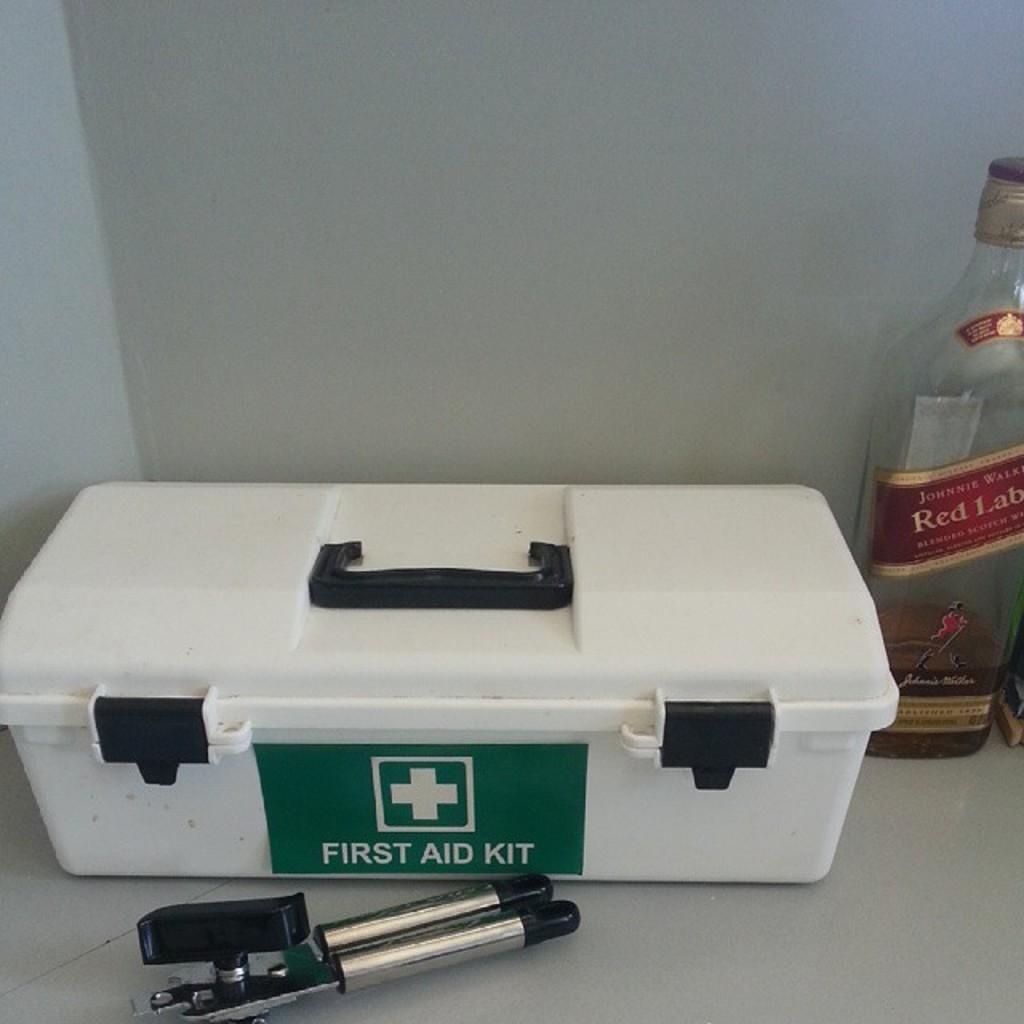What is the main object in the image? There is a white color box in the image. What else can be seen on the right side of the image? There is a bottle at the right side of the image. What is located in the front of the image? There is a tool in the front of the image. What type of pest can be seen crawling on the tool in the image? There are no pests visible in the image, and the tool is not being crawled on by any creature. 